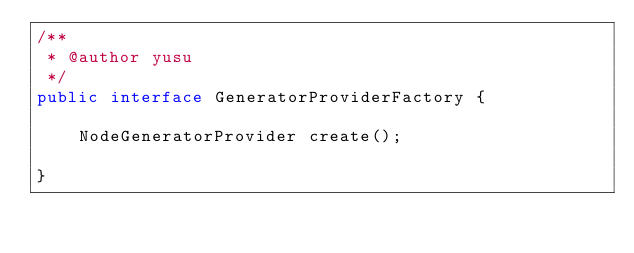Convert code to text. <code><loc_0><loc_0><loc_500><loc_500><_Java_>/**
 * @author yusu
 */
public interface GeneratorProviderFactory {

    NodeGeneratorProvider create();

}</code> 